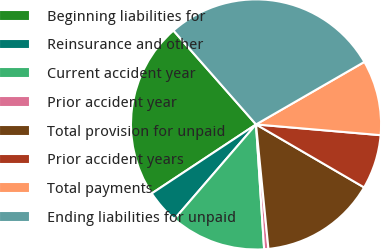Convert chart. <chart><loc_0><loc_0><loc_500><loc_500><pie_chart><fcel>Beginning liabilities for<fcel>Reinsurance and other<fcel>Current accident year<fcel>Prior accident year<fcel>Total provision for unpaid<fcel>Prior accident years<fcel>Total payments<fcel>Ending liabilities for unpaid<nl><fcel>22.82%<fcel>4.37%<fcel>12.36%<fcel>0.55%<fcel>15.02%<fcel>7.03%<fcel>9.7%<fcel>28.15%<nl></chart> 